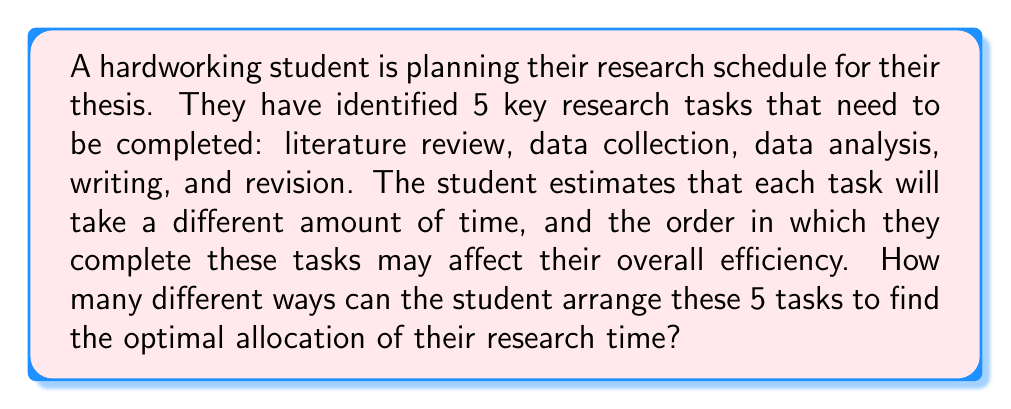What is the answer to this math problem? To solve this problem, we need to use the concept of permutations from combinatorics. A permutation is an arrangement of objects where order matters.

Step 1: Identify the number of objects to be arranged.
In this case, we have 5 research tasks: literature review, data collection, data analysis, writing, and revision.

Step 2: Determine if all objects are distinct.
Each task is different and unique, so all objects are indeed distinct.

Step 3: Apply the formula for permutations of n distinct objects.
The formula for permutations of n distinct objects is:

$$P(n) = n!$$

Where $n!$ represents the factorial of n.

Step 4: Calculate the result.
In our case, $n = 5$, so we need to calculate $5!$:

$$\begin{align}
5! &= 5 \times 4 \times 3 \times 2 \times 1 \\
&= 120
\end{align}$$

Therefore, there are 120 different ways the student can arrange their 5 research tasks.

This means the student has 120 different possible schedules to consider when trying to find the optimal allocation of their research time.
Answer: 120 